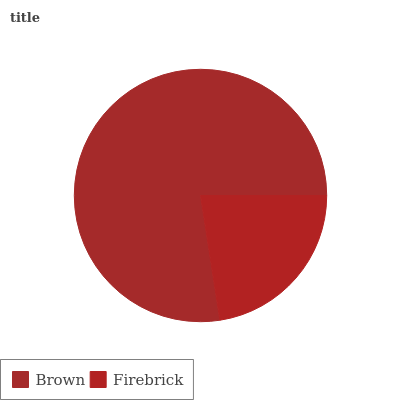Is Firebrick the minimum?
Answer yes or no. Yes. Is Brown the maximum?
Answer yes or no. Yes. Is Firebrick the maximum?
Answer yes or no. No. Is Brown greater than Firebrick?
Answer yes or no. Yes. Is Firebrick less than Brown?
Answer yes or no. Yes. Is Firebrick greater than Brown?
Answer yes or no. No. Is Brown less than Firebrick?
Answer yes or no. No. Is Brown the high median?
Answer yes or no. Yes. Is Firebrick the low median?
Answer yes or no. Yes. Is Firebrick the high median?
Answer yes or no. No. Is Brown the low median?
Answer yes or no. No. 